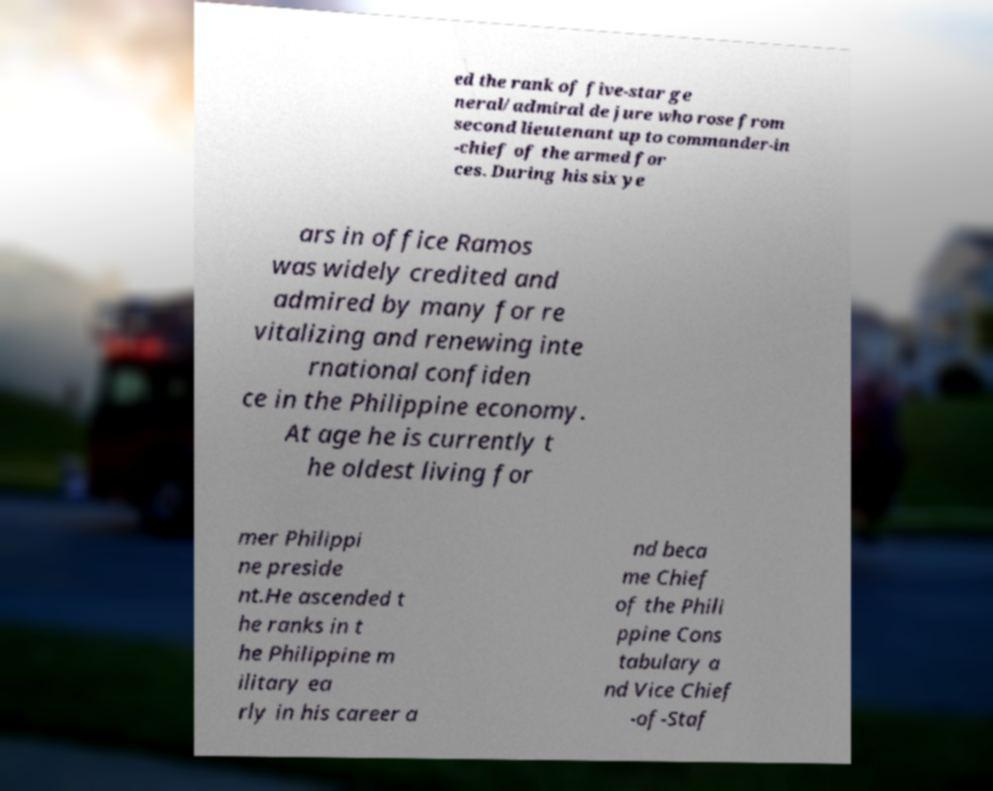Please read and relay the text visible in this image. What does it say? ed the rank of five-star ge neral/admiral de jure who rose from second lieutenant up to commander-in -chief of the armed for ces. During his six ye ars in office Ramos was widely credited and admired by many for re vitalizing and renewing inte rnational confiden ce in the Philippine economy. At age he is currently t he oldest living for mer Philippi ne preside nt.He ascended t he ranks in t he Philippine m ilitary ea rly in his career a nd beca me Chief of the Phili ppine Cons tabulary a nd Vice Chief -of-Staf 